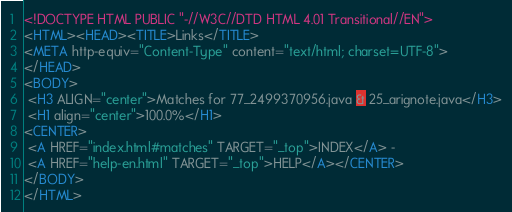Convert code to text. <code><loc_0><loc_0><loc_500><loc_500><_HTML_><!DOCTYPE HTML PUBLIC "-//W3C//DTD HTML 4.01 Transitional//EN">
<HTML><HEAD><TITLE>Links</TITLE>
<META http-equiv="Content-Type" content="text/html; charset=UTF-8">
</HEAD>
<BODY>
 <H3 ALIGN="center">Matches for 77_2499370956.java & 25_arignote.java</H3>
 <H1 align="center">100.0%</H1>
<CENTER>
 <A HREF="index.html#matches" TARGET="_top">INDEX</A> - 
 <A HREF="help-en.html" TARGET="_top">HELP</A></CENTER>
</BODY>
</HTML>
</code> 